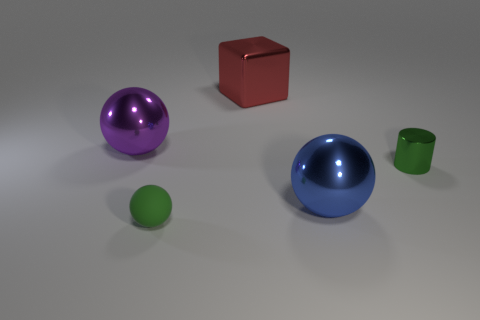Add 1 metal cylinders. How many objects exist? 6 Subtract all cylinders. How many objects are left? 4 Add 1 large yellow metal cylinders. How many large yellow metal cylinders exist? 1 Subtract 0 red cylinders. How many objects are left? 5 Subtract all metallic cylinders. Subtract all purple metal balls. How many objects are left? 3 Add 5 shiny cylinders. How many shiny cylinders are left? 6 